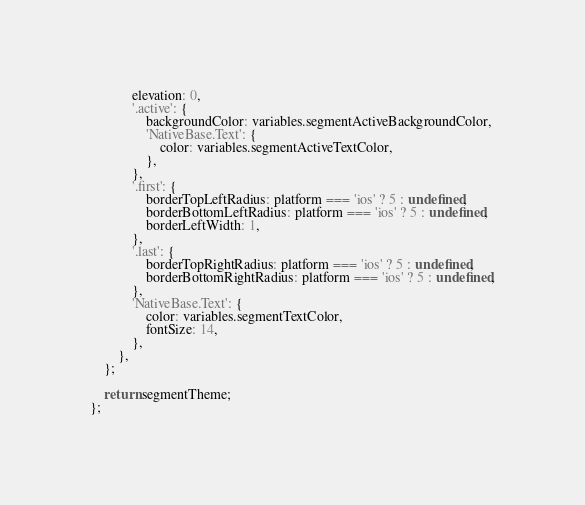<code> <loc_0><loc_0><loc_500><loc_500><_JavaScript_>			elevation: 0,
			'.active': {
				backgroundColor: variables.segmentActiveBackgroundColor,
				'NativeBase.Text': {
					color: variables.segmentActiveTextColor,
				},
			},
			'.first': {
				borderTopLeftRadius: platform === 'ios' ? 5 : undefined,
				borderBottomLeftRadius: platform === 'ios' ? 5 : undefined,
				borderLeftWidth: 1,
			},
			'.last': {
				borderTopRightRadius: platform === 'ios' ? 5 : undefined,
				borderBottomRightRadius: platform === 'ios' ? 5 : undefined,
			},
			'NativeBase.Text': {
				color: variables.segmentTextColor,
				fontSize: 14,
			},
		},
	};

	return segmentTheme;
};
</code> 